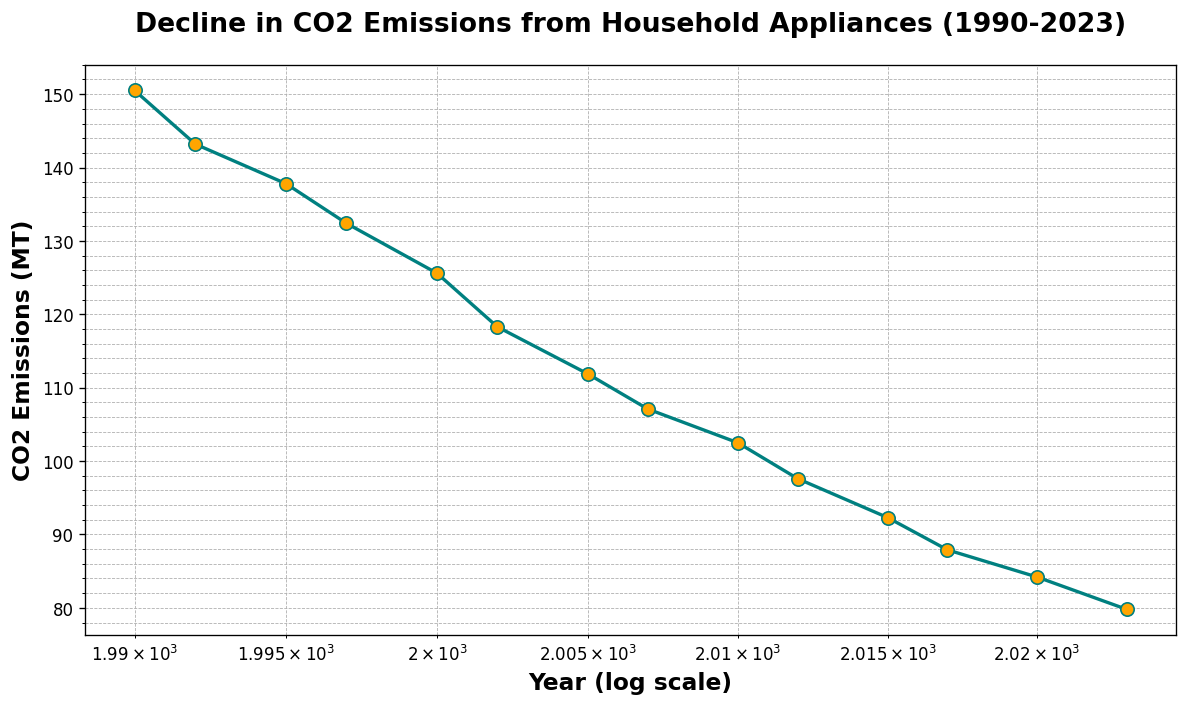What's the average CO2 emissions from household appliances between 1990 and 2023? To calculate the average CO2 emissions, sum up the values for all years and then divide by the number of years. The sum is (150.5 + 143.2 + 137.8 + 132.4 + 125.6 + 118.3 + 111.9 + 107.1 + 102.5 + 97.6 + 92.3 + 87.9 + 84.2 + 79.8) = 1571.1 and there are 14 years, so the average is 1571.1 / 14 = 112.22
Answer: 112.22 How much did CO2 emissions decrease between 1990 and 2023? Determine the CO2 emissions in 1990 and 2023, then calculate the difference. Emissions in 1990 are 150.5 MT, and in 2023, they are 79.8 MT. The decrease is 150.5 - 79.8 = 70.7 MT
Answer: 70.7 MT In which period did the CO2 emissions see the sharpest decline? By analyzing the slope of the line segments between consecutive years, the sharpest decline occurs where the vertical drop between points is greatest. The largest decrease appears between 1995 (137.8 MT) and 1997 (132.4 MT), which is a drop of 5.4 MT over 2 years
Answer: 1995-1997 Which year had the lowest CO2 emissions and what was the value? By observing the line graph, the lowest point occurs in 2023. The corresponding CO2 emissions value is 79.8 MT
Answer: 2023, 79.8 MT How does the CO2 emissions trend from 1990 to 2023 appear on a log scale? On a log scale, the years appear non-linear but regularly spaced, and the trend line depicts a consistent decrease in CO2 emissions over the years, indicating a steady reduction rate
Answer: Consistent decrease What visual clue indicates the trend of CO2 emissions over the years? The teal line with orange markers represents a decreasing trend over time, and the downward slope of the line indicates a decline in CO2 emissions from household appliances
Answer: Downward slope By what percentage did CO2 emissions reduce from 1990 (150.5 MT) to 2023 (79.8 MT)? The percentage reduction can be calculated using the formula: ((old value - new value) / old value) * 100. Therefore, ((150.5 - 79.8) / 150.5) * 100 = 46.99%
Answer: 46.99% In which year did the CO2 emissions drop below 100 MT for the first time? By examining the plotted values, the first year CO2 emissions dropped below 100 MT was in 2010 with an emissions value of 102.5 MT, and subsequently, in 2012 it was 97.6 MT
Answer: 2012 